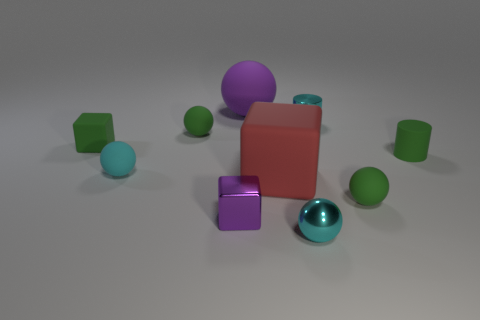Subtract all cyan metallic spheres. How many spheres are left? 4 Subtract all purple spheres. How many spheres are left? 4 Subtract all yellow spheres. Subtract all red cubes. How many spheres are left? 5 Subtract all cubes. How many objects are left? 7 Subtract all green spheres. Subtract all small green rubber cylinders. How many objects are left? 7 Add 3 large objects. How many large objects are left? 5 Add 7 metallic cylinders. How many metallic cylinders exist? 8 Subtract 1 green cylinders. How many objects are left? 9 